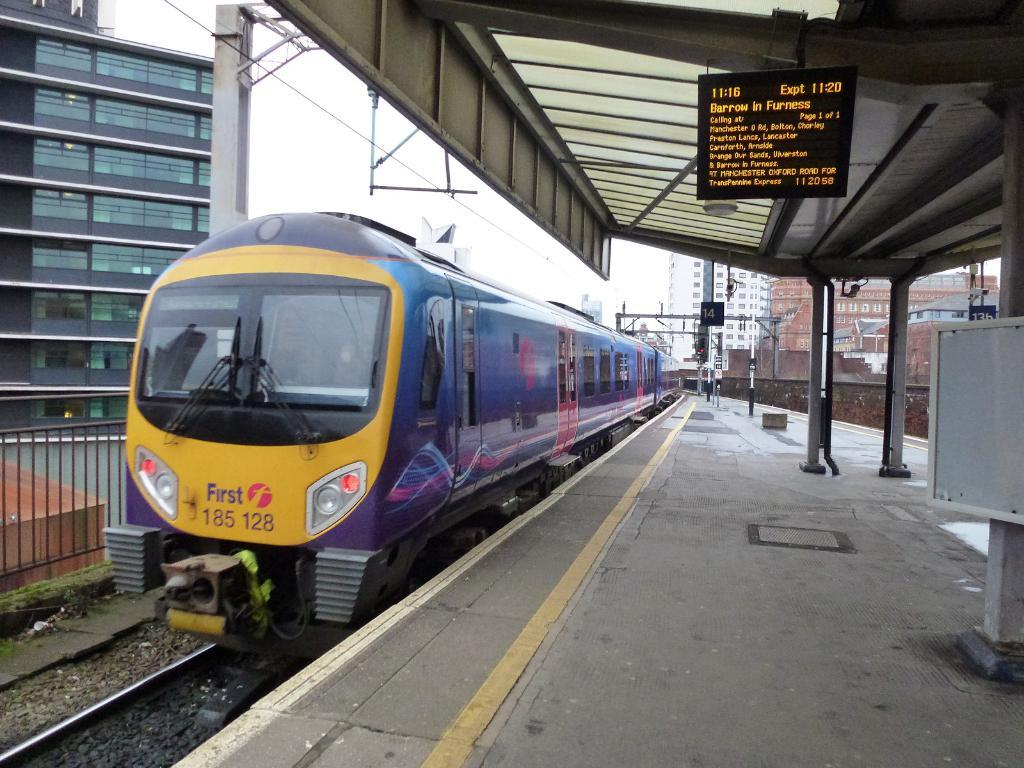Provide a one-sentence caption for the provided image. The number of this train is 185 128. 